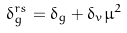Convert formula to latex. <formula><loc_0><loc_0><loc_500><loc_500>\delta _ { g } ^ { r s } = \delta _ { g } + \delta _ { v } \mu ^ { 2 }</formula> 